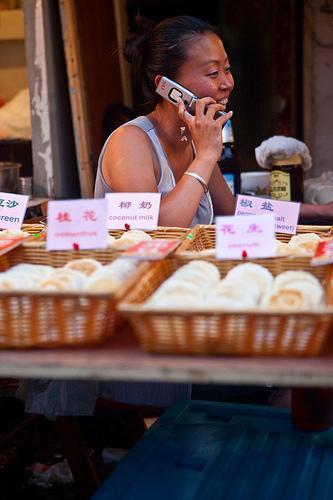How many baskets have coconut milk in it?
Give a very brief answer. 1. How many signs are in all of the baskets?
Give a very brief answer. 5. 